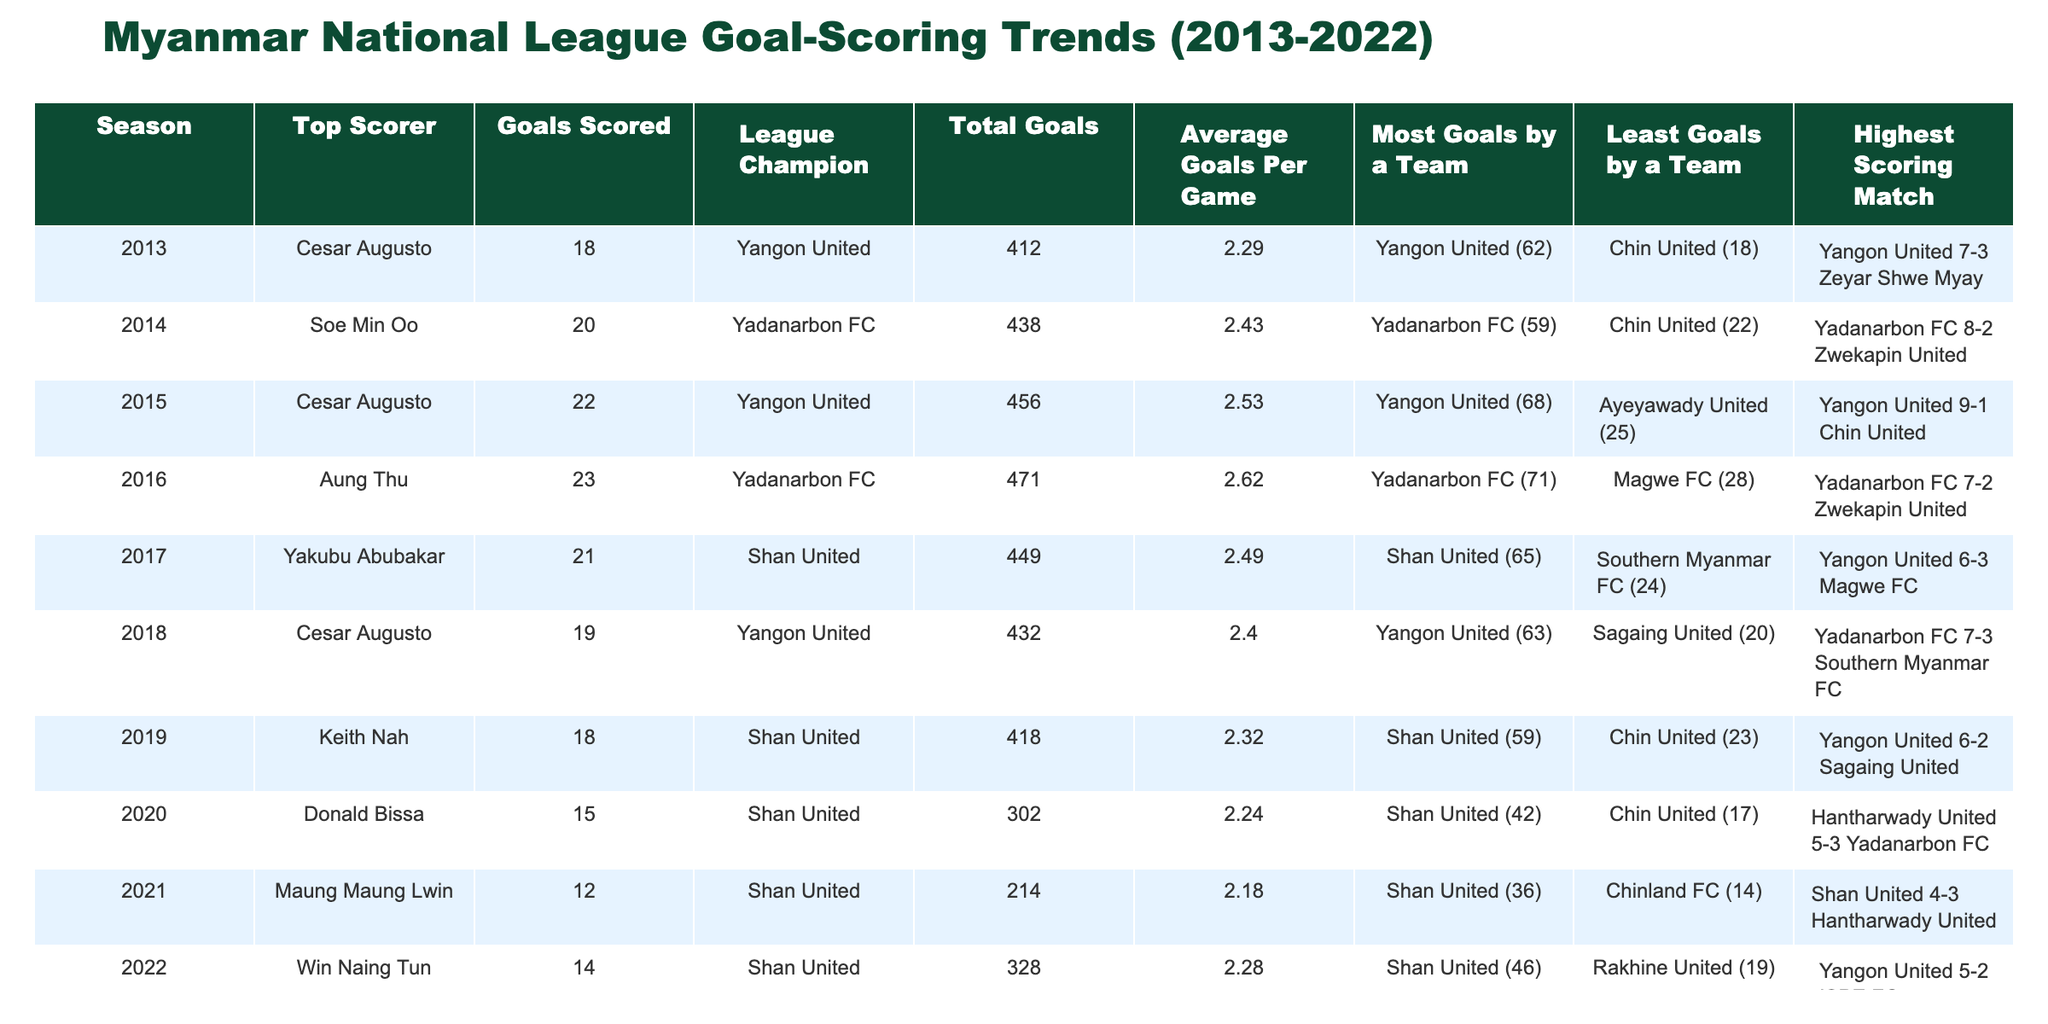What was the total number of goals scored in the 2015 season? According to the table, the total goals scored in the 2015 season are listed directly in that row. It states "Total Goals: 456." Therefore, it can be retrieved directly from the data.
Answer: 456 Which player scored the most goals in a single season during this period? From the table, the top scorers are Aung Thu (23 goals in 2016) and Cesar Augusto (22 goals in 2015). The highest number among these is 23. Thus, Aung Thu is the player who scored the most goals.
Answer: Aung Thu (23 goals) How many goals did the league champion Shan United score in total during the years they were champions? Shan United was the league champion in the seasons 2017, 2018, 2019, 2020, and 2021. The total goals for these seasons are 449, 432, 418, 302, and 214, respectively. To obtain the total, we sum these values: 449 + 432 + 418 + 302 + 214 = 1815.
Answer: 1815 Was there a season where the least goals were scored by a single team? According to the table, the least goals by a team were recorded as 14 by Chinland FC in 2021, which is the lowest in the data. This indicates that it is true that there was a season in which the least goals were scored.
Answer: Yes In which season did the average goals per game peak, and what was that average? By analyzing the average goals per game, we see that the highest average is listed for the 2016 season with 2.62 goals per game. Thus, 2016 is the season in which the average peaked.
Answer: 2016 (2.62) Which match had the highest score difference in this table? The highest scoring match recorded in the table is "Yangon United 9-1 Chin United" in 2015. The score difference is 8 goals (9-1 = 8). Comparing all match outcomes listed, this remains the greatest difference.
Answer: Yangon United 9-1 Chin United What was the trend in average goals per game from 2013 to 2022? The average goals per game values are 2.29, 2.43, 2.53, 2.62, 2.49, 2.40, 2.32, 2.24, 2.18, and 2.28 respectively across the seasons. Analyzing this, it can be seen that from 2013 to 2016, there is an upward trend, peaking in 2016, followed by a slight decline until 2021, then a minor increase in 2022.
Answer: It peaked in 2016, then slightly declined before increasing again in 2022 In how many years did Yadanarbon FC win the league, and what were those seasons? Yadanarbon FC was the league champion in 2014 and 2016. Thus, this club won the league twice during the provided decade.
Answer: 2 years (2014, 2016) 